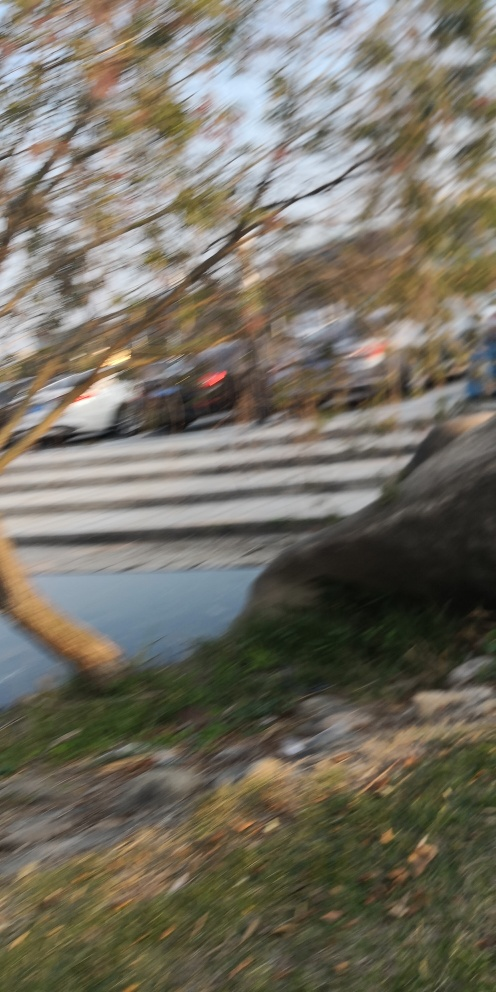What might have caused the blurriness in this picture? The blurriness in the picture could have been caused by several factors, such as camera shake during exposure, incorrect focus settings, or movement of the subject or camera. If it was taken with a handheld camera, even a slight movement could result in such a blur, especially if the shutter speed was not fast enough to freeze motion. 